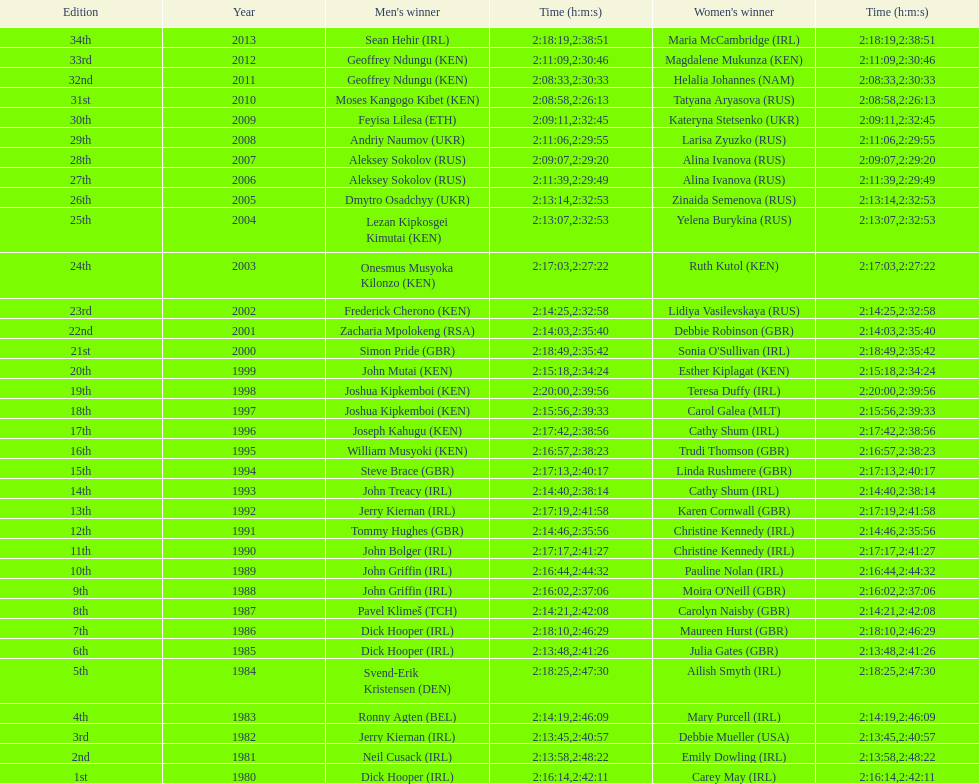How many women's victors are from kenya? 3. 